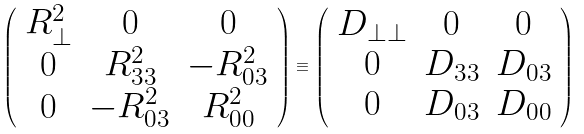Convert formula to latex. <formula><loc_0><loc_0><loc_500><loc_500>\left ( \begin{array} { c c c } R _ { \perp } ^ { 2 } & 0 & 0 \\ 0 & R _ { 3 3 } ^ { 2 } & - R _ { 0 3 } ^ { 2 } \\ 0 & - R _ { 0 3 } ^ { 2 } & R _ { 0 0 } ^ { 2 } \end{array} \right ) \equiv \left ( \begin{array} { c c c } D _ { \perp \perp } & 0 & 0 \\ 0 & D _ { 3 3 } & D _ { 0 3 } \\ 0 & D _ { 0 3 } & D _ { 0 0 } \end{array} \right )</formula> 